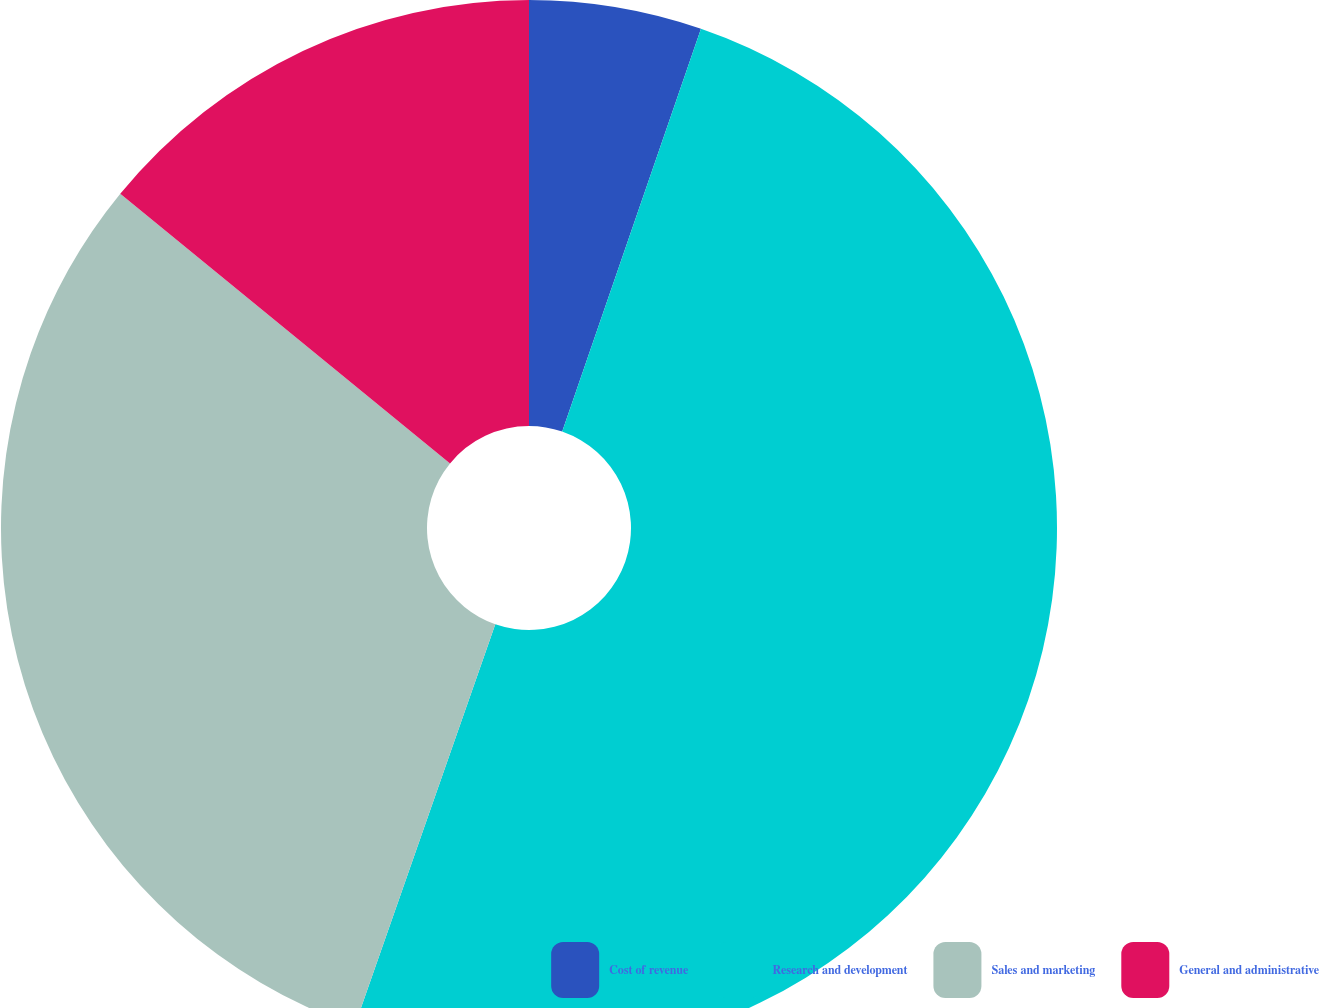Convert chart to OTSL. <chart><loc_0><loc_0><loc_500><loc_500><pie_chart><fcel>Cost of revenue<fcel>Research and development<fcel>Sales and marketing<fcel>General and administrative<nl><fcel>5.28%<fcel>50.08%<fcel>30.55%<fcel>14.09%<nl></chart> 